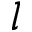<formula> <loc_0><loc_0><loc_500><loc_500>l</formula> 